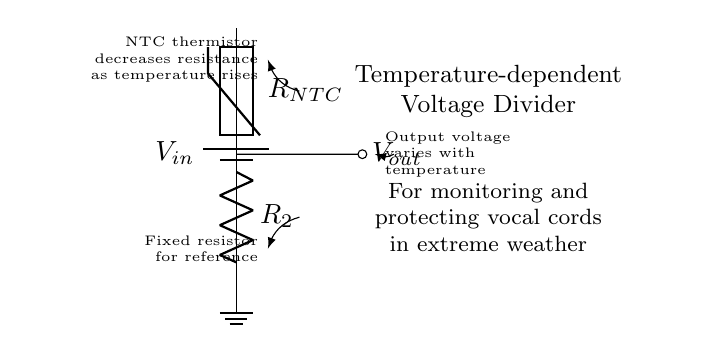What is the input voltage of the circuit? The input voltage is labeled as Vin in the circuit diagram, which is the voltage supplied to the circuit.
Answer: Vin What type of resistor is used in this circuit? The circuit diagram specifies that an NTC thermistor is used, indicated by the label RNTC, which decreases resistance as the temperature rises.
Answer: NTC thermistor How does the output voltage vary with temperature? The output voltage, labeled as Vout, changes according to the resistance values of the components in the circuit; as the NTC thermistor's resistance decreases with rising temperature, Vout increases.
Answer: Vout increases What is the purpose of the fixed resistor in the circuit? The fixed resistor, labeled as R2, serves as a reference resistor in the voltage divider configuration, providing stability in the output voltage readings.
Answer: Reference resistor What does a lower temperature do to the NTC thermistor's resistance? A lower temperature increases the resistance of the NTC thermistor due to its negative temperature coefficient characteristic, which is key in determining Vout.
Answer: Increases resistance What happens to Vout when temperature increases? When the temperature increases, the resistance of the NTC thermistor decreases, causing the voltage Vout to rise as per the voltage divider principle.
Answer: Vout rises 